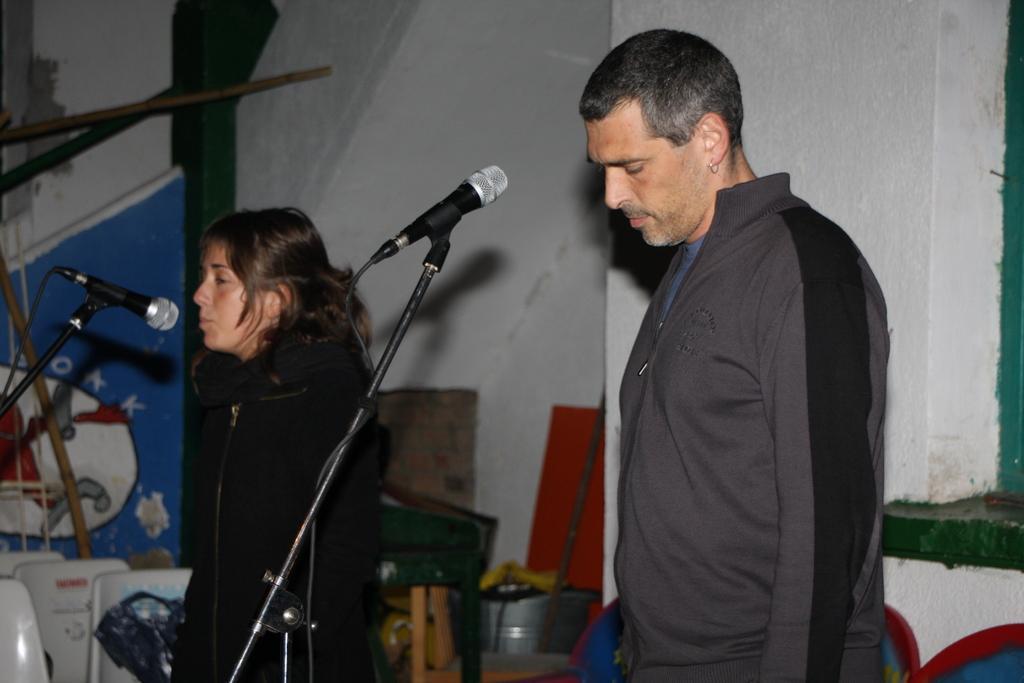Could you give a brief overview of what you see in this image? In this image there is a man in the middle. In front of him there is a mic. Beside him there is a girl standing on the floor. In front of her there is a mic. In the background there are chairs at the bottom. On the right side there is a wall. 